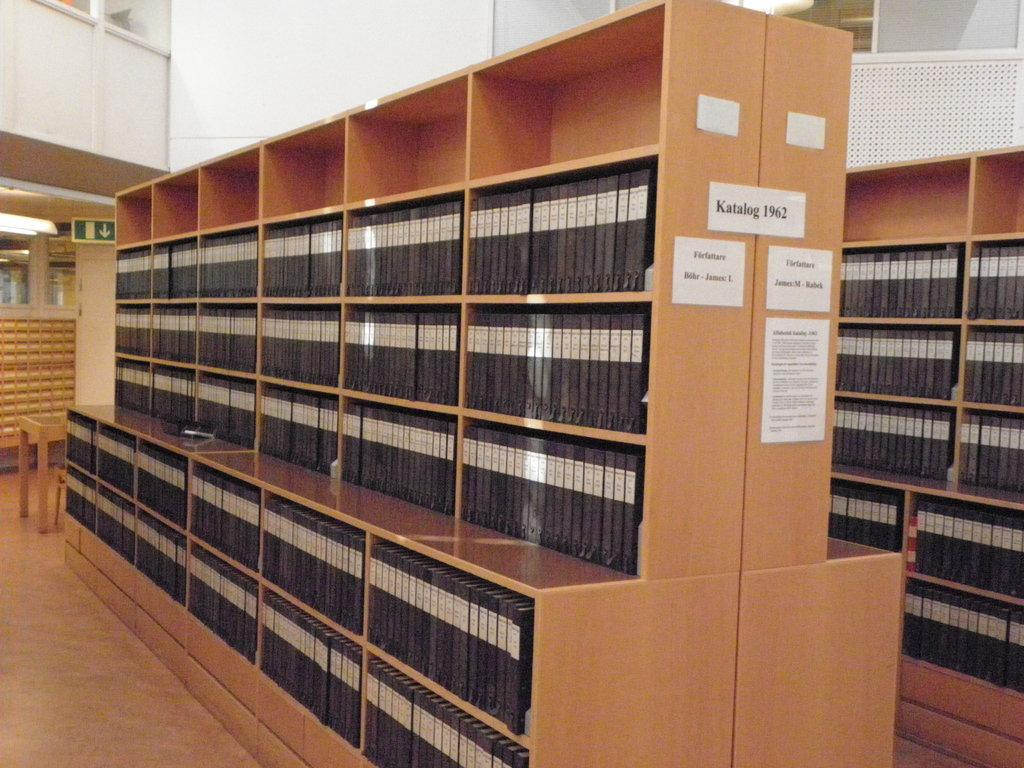Provide a one-sentence caption for the provided image. a brown case with the word katalog on it. 